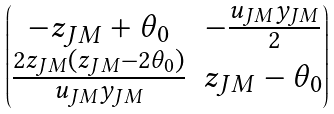<formula> <loc_0><loc_0><loc_500><loc_500>\begin{pmatrix} - z _ { J M } + \theta _ { 0 } & - \frac { u _ { J M } y _ { J M } } { 2 } \\ \frac { 2 z _ { J M } ( z _ { J M } - 2 \theta _ { 0 } ) } { u _ { J M } y _ { J M } } & z _ { J M } - \theta _ { 0 } \end{pmatrix}</formula> 